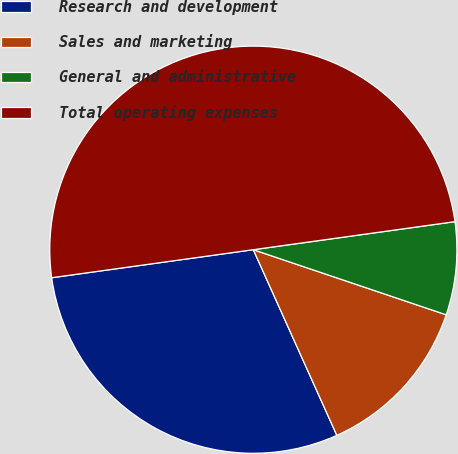Convert chart to OTSL. <chart><loc_0><loc_0><loc_500><loc_500><pie_chart><fcel>Research and development<fcel>Sales and marketing<fcel>General and administrative<fcel>Total operating expenses<nl><fcel>29.53%<fcel>13.09%<fcel>7.38%<fcel>50.0%<nl></chart> 